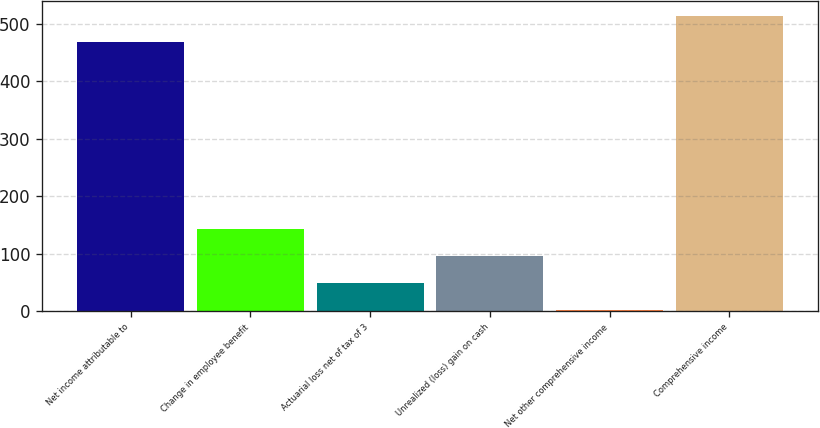Convert chart. <chart><loc_0><loc_0><loc_500><loc_500><bar_chart><fcel>Net income attributable to<fcel>Change in employee benefit<fcel>Actuarial loss net of tax of 3<fcel>Unrealized (loss) gain on cash<fcel>Net other comprehensive income<fcel>Comprehensive income<nl><fcel>468<fcel>142.4<fcel>48.8<fcel>95.6<fcel>2<fcel>514.8<nl></chart> 